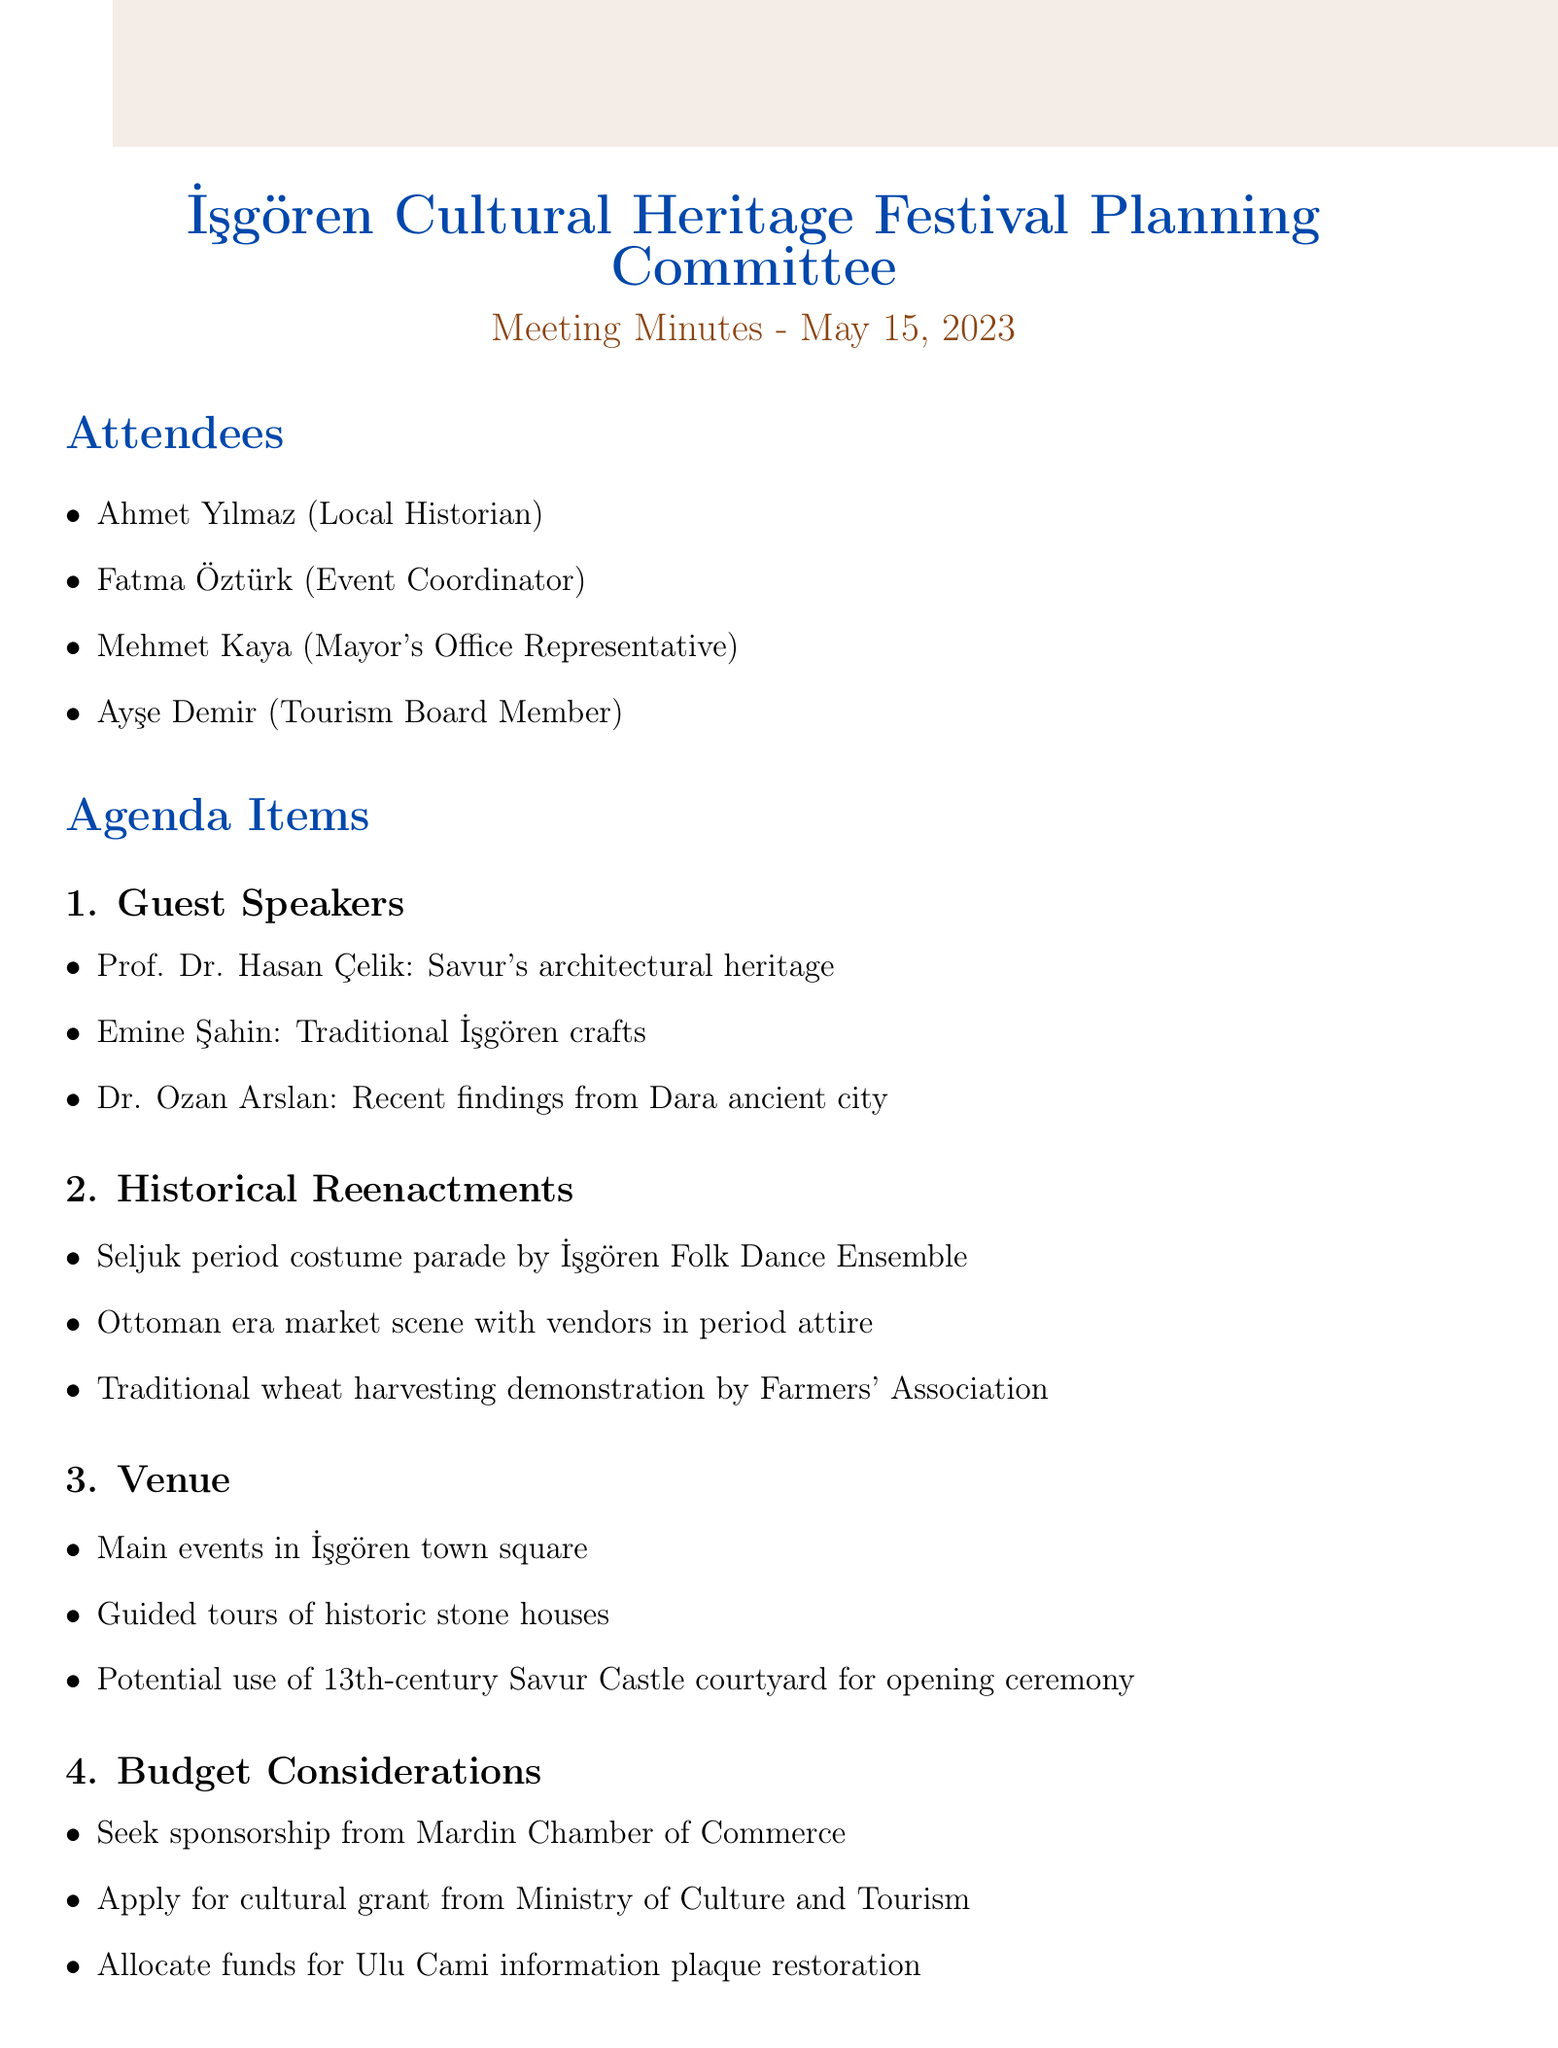what is the date of the meeting? The date of the meeting is provided at the beginning of the document.
Answer: May 15, 2023 who is the local artisan guest speaker? The guest speakers are listed under the Guest Speakers agenda item.
Answer: Emine Şahin what is the venue for the main events? The venue for the main events is mentioned under the Venue section.
Answer: İşgören town square how many guest speakers are there? The number of guest speakers can be determined by counting the details under the Guest Speakers section.
Answer: 3 who is responsible for confirming the availability of guest speakers? The action items list who is responsible for each task related to the meeting.
Answer: Fatma what is planned for historical reenactments? The historical reenactments details provide insights into what is planned for the festival.
Answer: Seljuk period costume parade when is the next meeting scheduled? The next meeting date is listed at the end of the document.
Answer: June 5, 2023 what type of demonstration will the İşgören Farmers' Association perform? The type of demonstration can be found in the Historical Reenactments section.
Answer: Traditional wheat harvesting techniques where will guided tours of historic sites be organized? This information is mentioned in the Venue section of the document.
Answer: İşgören's historic stone houses 